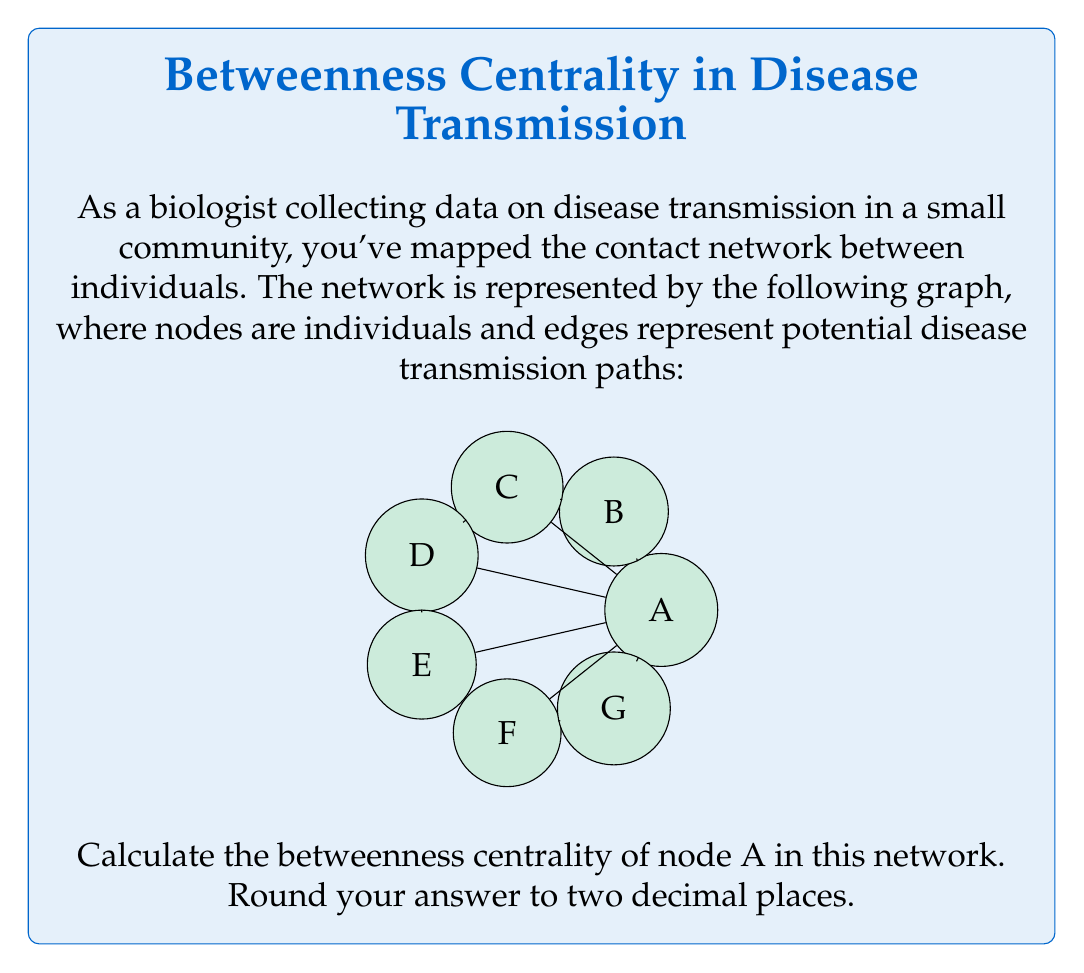Could you help me with this problem? To solve this problem, we need to follow these steps:

1) Betweenness centrality of a node v is calculated as:

   $$ C_B(v) = \sum_{s \neq v \neq t} \frac{\sigma_{st}(v)}{\sigma_{st}} $$

   where $\sigma_{st}$ is the total number of shortest paths from node s to node t, and $\sigma_{st}(v)$ is the number of those paths that pass through v.

2) In this network, we need to consider all pairs of nodes excluding A, and count how many shortest paths between them pass through A.

3) Let's consider each pair:

   B-C, B-D, B-E, B-F, B-G: None of these shortest paths pass through A
   C-D, C-E, C-F, C-G: All of these have shortest paths through A (1 out of 1)
   D-E, D-F, D-G: All of these have shortest paths through A (1 out of 1)
   E-F, E-G: All of these have shortest paths through A (1 out of 1)
   F-G: This doesn't pass through A

4) Counting the pairs where A is on the shortest path:
   4 (from C) + 3 (from D) + 2 (from E) = 9 pairs

5) For each of these 9 pairs, there's only one shortest path, and it passes through A. So for each, $\frac{\sigma_{st}(A)}{\sigma_{st}} = 1$

6) Therefore, the betweenness centrality of A is simply 9.

7) To normalize this, we divide by the number of possible pairs of nodes excluding A:
   $\binom{6}{2} = 15$

8) Normalized betweenness centrality: $9 / 15 = 0.6$
Answer: 0.60 